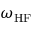<formula> <loc_0><loc_0><loc_500><loc_500>\omega _ { H F }</formula> 